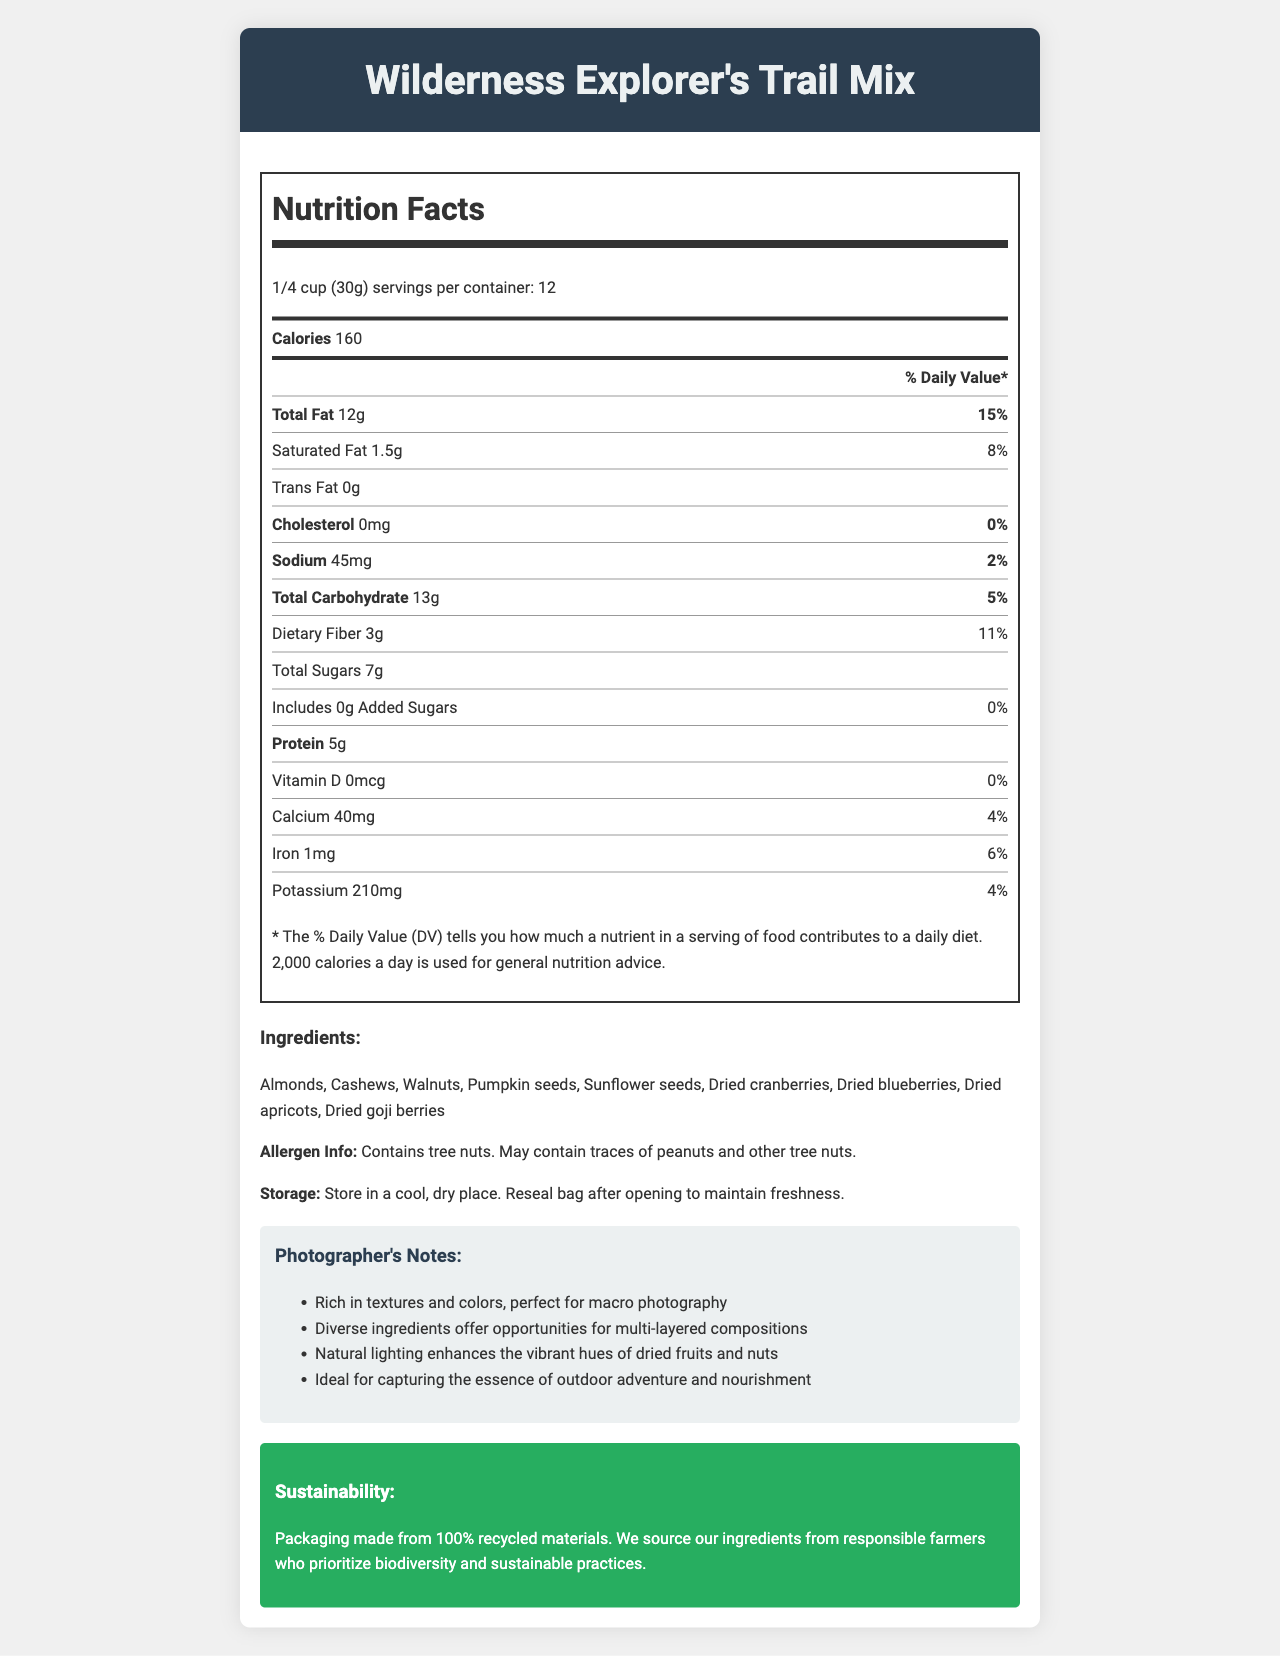What is the serving size of Wilderness Explorer's Trail Mix? The document specifies the serving size directly in the nutrition facts section.
Answer: 1/4 cup (30g) How many calories are in one serving? The document states that each serving contains 160 calories.
Answer: 160 What is the amount of protein per serving? The document lists the protein content as 5g per serving.
Answer: 5g Does the trail mix contain any trans fat? The document shows that the trans fat content is 0g.
Answer: No What is the daily value percentage of dietary fiber per serving? The daily value percentage for dietary fiber is mentioned as 11% in the nutrition facts section.
Answer: 11% Which vitamin is not present in the trail mix? 
A. Vitamin A
B. Vitamin D
C. Vitamin C The document indicates that Vitamin D is 0mcg with 0% daily value, implying it's not present.
Answer: B What is the daily value percentage of calcium per serving?
A. 2%
B. 4%
C. 6%
D. 8% The document mentions that calcium is 40mg and the daily value is 4%.
Answer: B Is there added sugar in the trail mix? The document states that the amount of added sugars is 0g with a daily value of 0%.
Answer: No Describe the main purpose of the document. This summary encapsulates all the key sections covered in the document, such as nutrition facts, ingredients, and various notes.
Answer: The document provides detailed nutritional information, ingredients, allergen info, storage instructions, photographer’s notes, and sustainability information about Wilderness Explorer's Trail Mix. What are the primary allergens in this trail mix? The allergen information section mentions that it contains tree nuts and may contain traces of peanuts and other tree nuts.
Answer: Tree nuts Where should the trail mix be stored? The storage instructions in the document specify this information clearly.
Answer: In a cool, dry place. Reseal the bag after opening to maintain freshness. How many grams of total fat are there per serving? The total fat amount per serving is listed as 12g in the nutrition facts section.
Answer: 12g What sustainability practices are mentioned regarding the packaging and ingredients? The sustainability info section elaborates on the eco-friendly packaging and responsible sourcing of ingredients.
Answer: Packaging made from 100% recycled materials. Ingredients sourced from responsible farmers who prioritize biodiversity and sustainable practices. What are the different dried fruits included in this trail mix? The ingredient list mentions these specific dried fruits.
Answer: Cranberries, blueberries, apricots, goji berries What comment is made about the potential for capturing the essence of "outdoor adventure and nourishment” in the photographer's notes? This phrase is explicitly stated in the photographer's notes section.
Answer: Ideal for capturing the essence of outdoor adventure and nourishment. Can you determine where the nuts used in the trail mix are sourced from? The document doesn’t provide any specific information about the sourcing location of the nuts.
Answer: Cannot be determined 